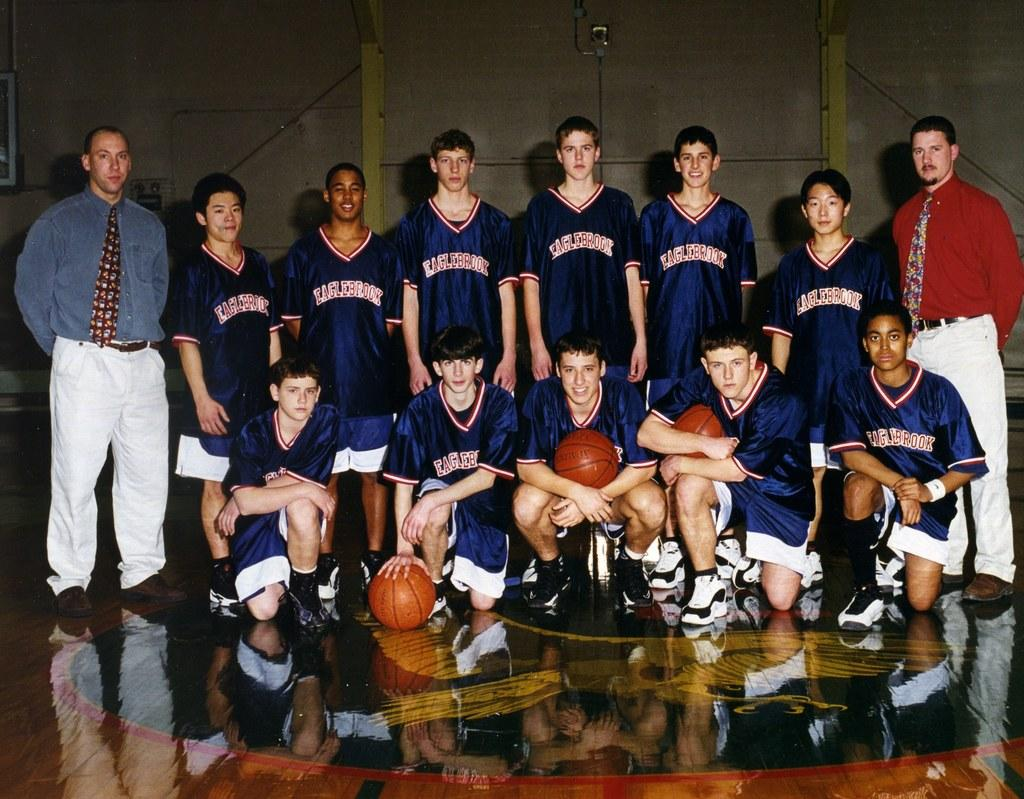<image>
Offer a succinct explanation of the picture presented. A youth basketball team is posing on the court and wearing jerseys that say Eaglebrook. 